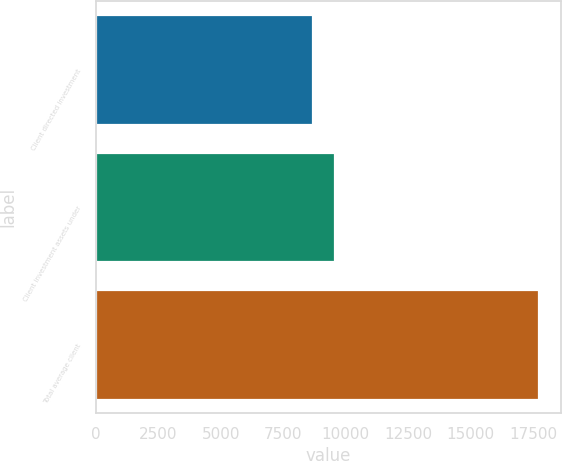Convert chart to OTSL. <chart><loc_0><loc_0><loc_500><loc_500><bar_chart><fcel>Client directed investment<fcel>Client investment assets under<fcel>Total average client<nl><fcel>8683<fcel>9588.3<fcel>17736<nl></chart> 